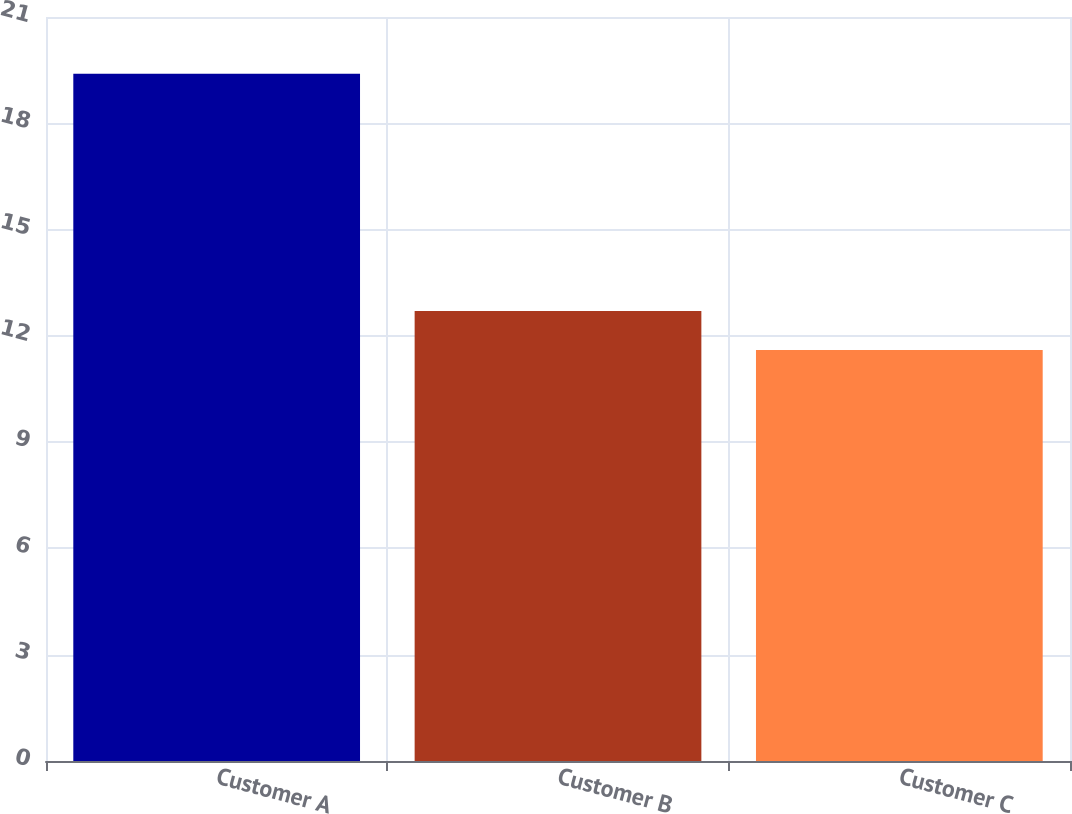Convert chart. <chart><loc_0><loc_0><loc_500><loc_500><bar_chart><fcel>Customer A<fcel>Customer B<fcel>Customer C<nl><fcel>19.4<fcel>12.7<fcel>11.6<nl></chart> 